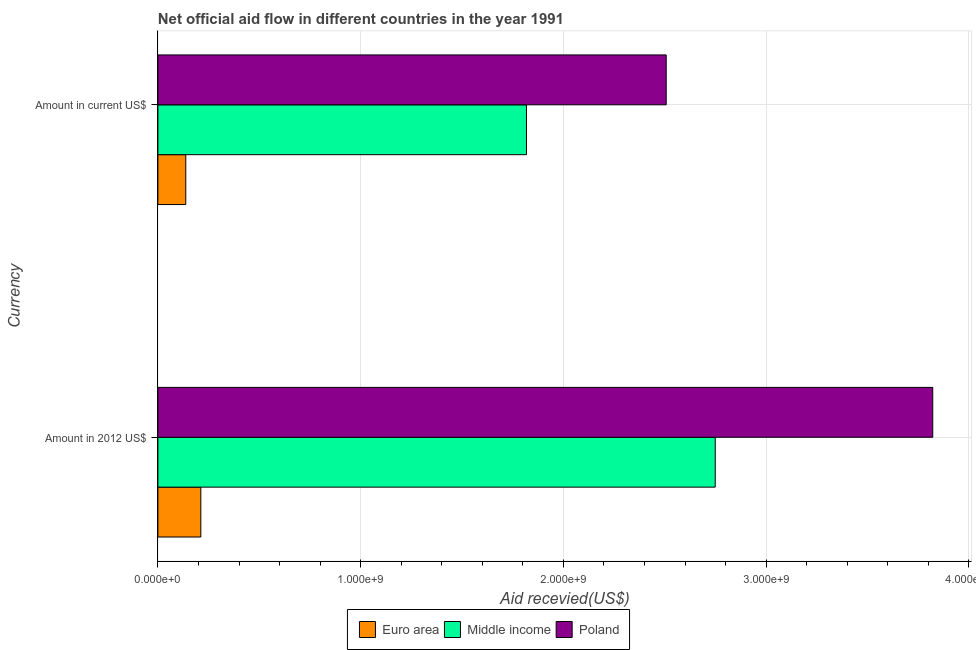How many groups of bars are there?
Keep it short and to the point. 2. Are the number of bars per tick equal to the number of legend labels?
Your response must be concise. Yes. Are the number of bars on each tick of the Y-axis equal?
Your answer should be very brief. Yes. How many bars are there on the 2nd tick from the top?
Give a very brief answer. 3. How many bars are there on the 2nd tick from the bottom?
Your answer should be very brief. 3. What is the label of the 1st group of bars from the top?
Offer a very short reply. Amount in current US$. What is the amount of aid received(expressed in 2012 us$) in Middle income?
Your answer should be very brief. 2.75e+09. Across all countries, what is the maximum amount of aid received(expressed in 2012 us$)?
Your answer should be compact. 3.82e+09. Across all countries, what is the minimum amount of aid received(expressed in us$)?
Give a very brief answer. 1.37e+08. In which country was the amount of aid received(expressed in us$) maximum?
Provide a succinct answer. Poland. What is the total amount of aid received(expressed in 2012 us$) in the graph?
Make the answer very short. 6.78e+09. What is the difference between the amount of aid received(expressed in us$) in Middle income and that in Poland?
Your answer should be very brief. -6.89e+08. What is the difference between the amount of aid received(expressed in 2012 us$) in Poland and the amount of aid received(expressed in us$) in Middle income?
Provide a short and direct response. 2.00e+09. What is the average amount of aid received(expressed in us$) per country?
Ensure brevity in your answer.  1.49e+09. What is the difference between the amount of aid received(expressed in us$) and amount of aid received(expressed in 2012 us$) in Euro area?
Your answer should be compact. -7.43e+07. What is the ratio of the amount of aid received(expressed in 2012 us$) in Euro area to that in Poland?
Offer a very short reply. 0.06. In how many countries, is the amount of aid received(expressed in us$) greater than the average amount of aid received(expressed in us$) taken over all countries?
Offer a terse response. 2. Are all the bars in the graph horizontal?
Your answer should be compact. Yes. What is the difference between two consecutive major ticks on the X-axis?
Offer a very short reply. 1.00e+09. Are the values on the major ticks of X-axis written in scientific E-notation?
Provide a short and direct response. Yes. Does the graph contain any zero values?
Make the answer very short. No. How many legend labels are there?
Give a very brief answer. 3. What is the title of the graph?
Keep it short and to the point. Net official aid flow in different countries in the year 1991. Does "Latin America(all income levels)" appear as one of the legend labels in the graph?
Ensure brevity in your answer.  No. What is the label or title of the X-axis?
Give a very brief answer. Aid recevied(US$). What is the label or title of the Y-axis?
Provide a short and direct response. Currency. What is the Aid recevied(US$) of Euro area in Amount in 2012 US$?
Give a very brief answer. 2.12e+08. What is the Aid recevied(US$) in Middle income in Amount in 2012 US$?
Offer a very short reply. 2.75e+09. What is the Aid recevied(US$) in Poland in Amount in 2012 US$?
Keep it short and to the point. 3.82e+09. What is the Aid recevied(US$) in Euro area in Amount in current US$?
Provide a succinct answer. 1.37e+08. What is the Aid recevied(US$) of Middle income in Amount in current US$?
Provide a short and direct response. 1.82e+09. What is the Aid recevied(US$) in Poland in Amount in current US$?
Ensure brevity in your answer.  2.51e+09. Across all Currency, what is the maximum Aid recevied(US$) of Euro area?
Keep it short and to the point. 2.12e+08. Across all Currency, what is the maximum Aid recevied(US$) in Middle income?
Keep it short and to the point. 2.75e+09. Across all Currency, what is the maximum Aid recevied(US$) in Poland?
Provide a succinct answer. 3.82e+09. Across all Currency, what is the minimum Aid recevied(US$) of Euro area?
Keep it short and to the point. 1.37e+08. Across all Currency, what is the minimum Aid recevied(US$) in Middle income?
Ensure brevity in your answer.  1.82e+09. Across all Currency, what is the minimum Aid recevied(US$) of Poland?
Your answer should be very brief. 2.51e+09. What is the total Aid recevied(US$) of Euro area in the graph?
Provide a succinct answer. 3.49e+08. What is the total Aid recevied(US$) of Middle income in the graph?
Your answer should be compact. 4.57e+09. What is the total Aid recevied(US$) in Poland in the graph?
Give a very brief answer. 6.33e+09. What is the difference between the Aid recevied(US$) of Euro area in Amount in 2012 US$ and that in Amount in current US$?
Keep it short and to the point. 7.43e+07. What is the difference between the Aid recevied(US$) of Middle income in Amount in 2012 US$ and that in Amount in current US$?
Provide a succinct answer. 9.31e+08. What is the difference between the Aid recevied(US$) in Poland in Amount in 2012 US$ and that in Amount in current US$?
Your response must be concise. 1.31e+09. What is the difference between the Aid recevied(US$) in Euro area in Amount in 2012 US$ and the Aid recevied(US$) in Middle income in Amount in current US$?
Your answer should be very brief. -1.61e+09. What is the difference between the Aid recevied(US$) in Euro area in Amount in 2012 US$ and the Aid recevied(US$) in Poland in Amount in current US$?
Offer a very short reply. -2.30e+09. What is the difference between the Aid recevied(US$) in Middle income in Amount in 2012 US$ and the Aid recevied(US$) in Poland in Amount in current US$?
Give a very brief answer. 2.42e+08. What is the average Aid recevied(US$) in Euro area per Currency?
Your response must be concise. 1.75e+08. What is the average Aid recevied(US$) in Middle income per Currency?
Keep it short and to the point. 2.28e+09. What is the average Aid recevied(US$) in Poland per Currency?
Keep it short and to the point. 3.16e+09. What is the difference between the Aid recevied(US$) in Euro area and Aid recevied(US$) in Middle income in Amount in 2012 US$?
Make the answer very short. -2.54e+09. What is the difference between the Aid recevied(US$) in Euro area and Aid recevied(US$) in Poland in Amount in 2012 US$?
Provide a succinct answer. -3.61e+09. What is the difference between the Aid recevied(US$) in Middle income and Aid recevied(US$) in Poland in Amount in 2012 US$?
Offer a terse response. -1.07e+09. What is the difference between the Aid recevied(US$) in Euro area and Aid recevied(US$) in Middle income in Amount in current US$?
Provide a succinct answer. -1.68e+09. What is the difference between the Aid recevied(US$) of Euro area and Aid recevied(US$) of Poland in Amount in current US$?
Your response must be concise. -2.37e+09. What is the difference between the Aid recevied(US$) in Middle income and Aid recevied(US$) in Poland in Amount in current US$?
Your answer should be very brief. -6.89e+08. What is the ratio of the Aid recevied(US$) in Euro area in Amount in 2012 US$ to that in Amount in current US$?
Your answer should be compact. 1.54. What is the ratio of the Aid recevied(US$) in Middle income in Amount in 2012 US$ to that in Amount in current US$?
Offer a very short reply. 1.51. What is the ratio of the Aid recevied(US$) in Poland in Amount in 2012 US$ to that in Amount in current US$?
Keep it short and to the point. 1.52. What is the difference between the highest and the second highest Aid recevied(US$) of Euro area?
Your response must be concise. 7.43e+07. What is the difference between the highest and the second highest Aid recevied(US$) in Middle income?
Provide a succinct answer. 9.31e+08. What is the difference between the highest and the second highest Aid recevied(US$) of Poland?
Provide a short and direct response. 1.31e+09. What is the difference between the highest and the lowest Aid recevied(US$) of Euro area?
Offer a terse response. 7.43e+07. What is the difference between the highest and the lowest Aid recevied(US$) of Middle income?
Keep it short and to the point. 9.31e+08. What is the difference between the highest and the lowest Aid recevied(US$) in Poland?
Your answer should be very brief. 1.31e+09. 